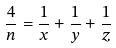Convert formula to latex. <formula><loc_0><loc_0><loc_500><loc_500>\frac { 4 } { n } = \frac { 1 } { x } + \frac { 1 } { y } + \frac { 1 } { z }</formula> 